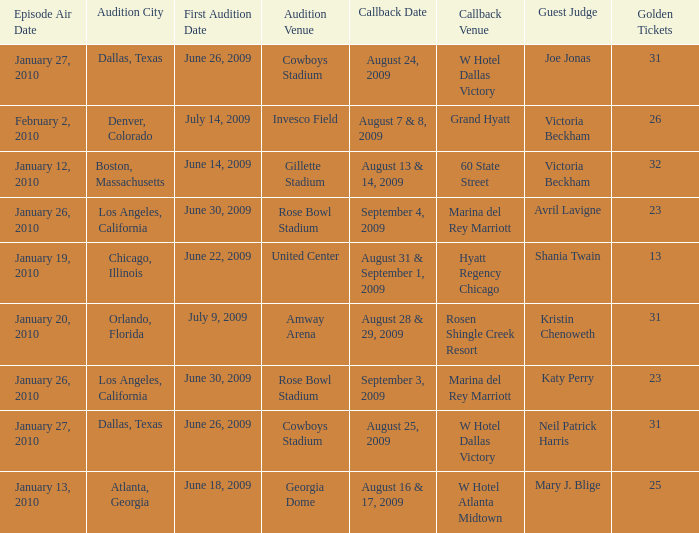Name the audition city for hyatt regency chicago Chicago, Illinois. 